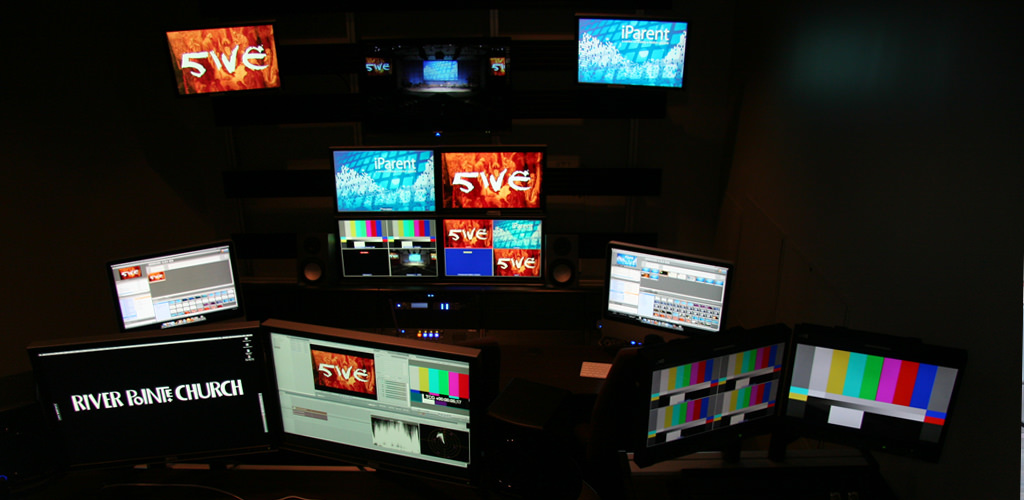Can you describe what might be the purpose of each type of monitor shown in this image? The layout suggests a multifunctional media room. The top monitors could be used for video previewing, the bottom wide screens might display timelines or multimedia editing tools, and the central labeled displays seem to be dedicated to monitoring specific content channels or feeds. 